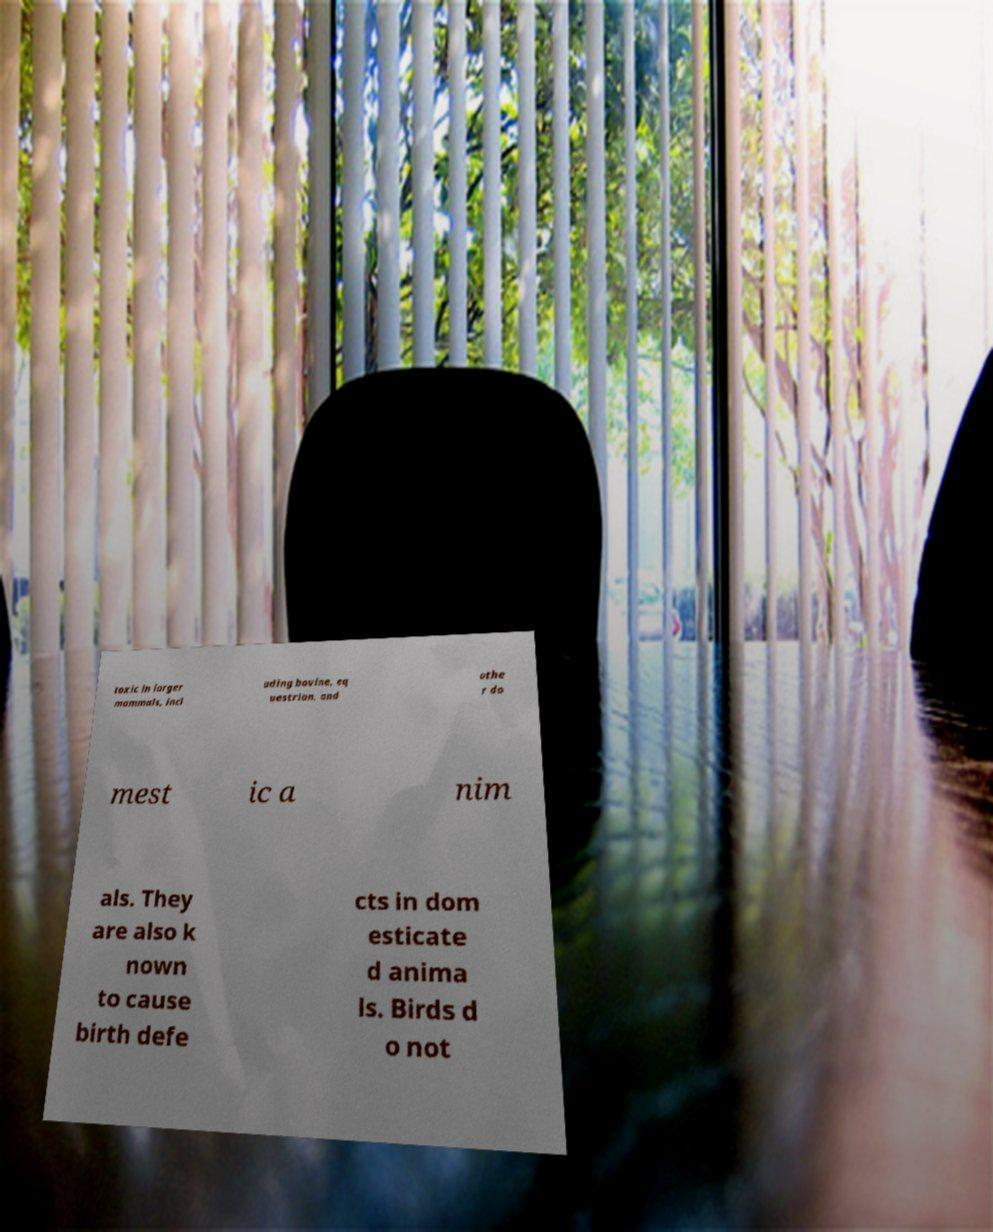For documentation purposes, I need the text within this image transcribed. Could you provide that? toxic in larger mammals, incl uding bovine, eq uestrian, and othe r do mest ic a nim als. They are also k nown to cause birth defe cts in dom esticate d anima ls. Birds d o not 